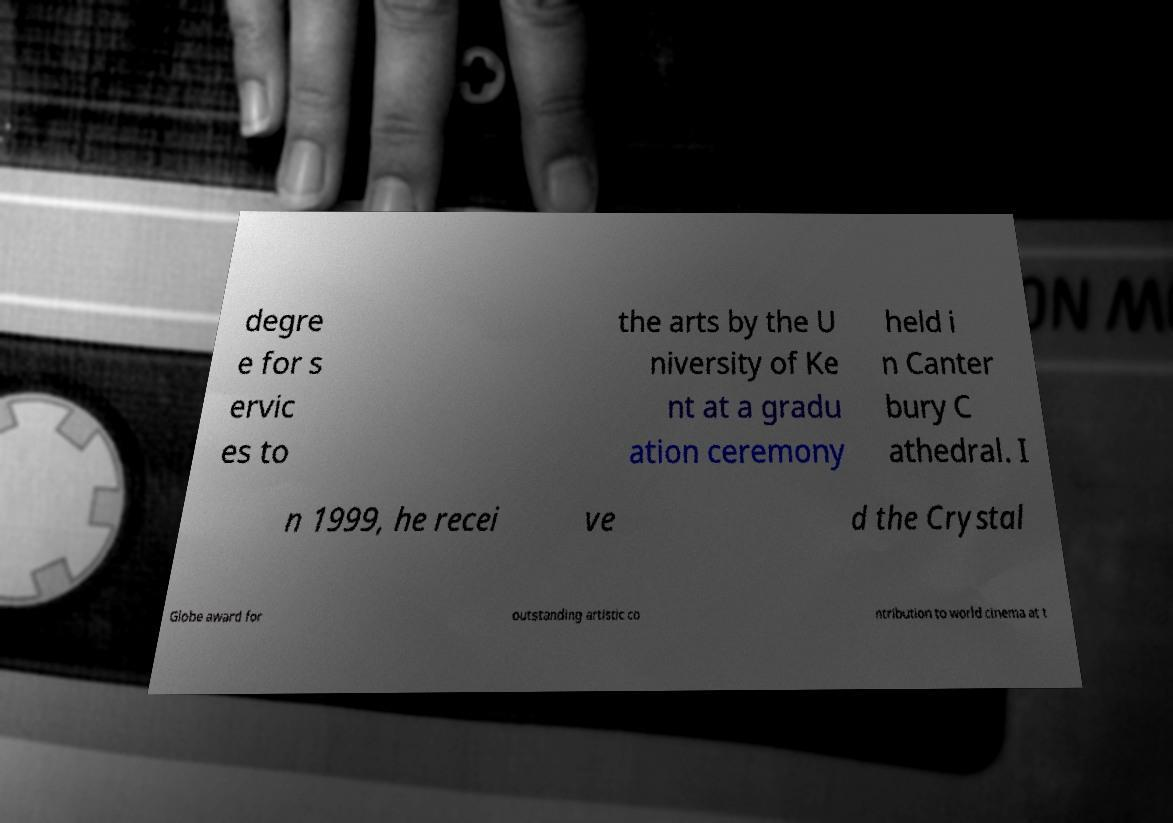Please identify and transcribe the text found in this image. degre e for s ervic es to the arts by the U niversity of Ke nt at a gradu ation ceremony held i n Canter bury C athedral. I n 1999, he recei ve d the Crystal Globe award for outstanding artistic co ntribution to world cinema at t 